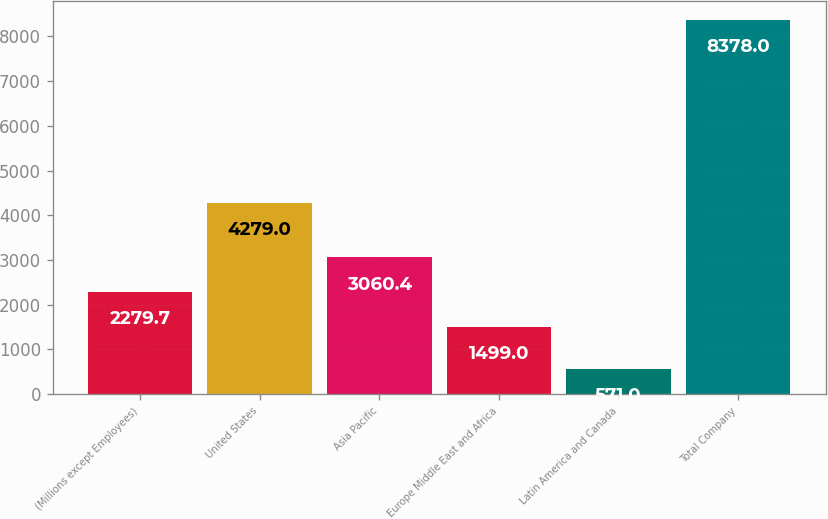Convert chart. <chart><loc_0><loc_0><loc_500><loc_500><bar_chart><fcel>(Millions except Employees)<fcel>United States<fcel>Asia Pacific<fcel>Europe Middle East and Africa<fcel>Latin America and Canada<fcel>Total Company<nl><fcel>2279.7<fcel>4279<fcel>3060.4<fcel>1499<fcel>571<fcel>8378<nl></chart> 